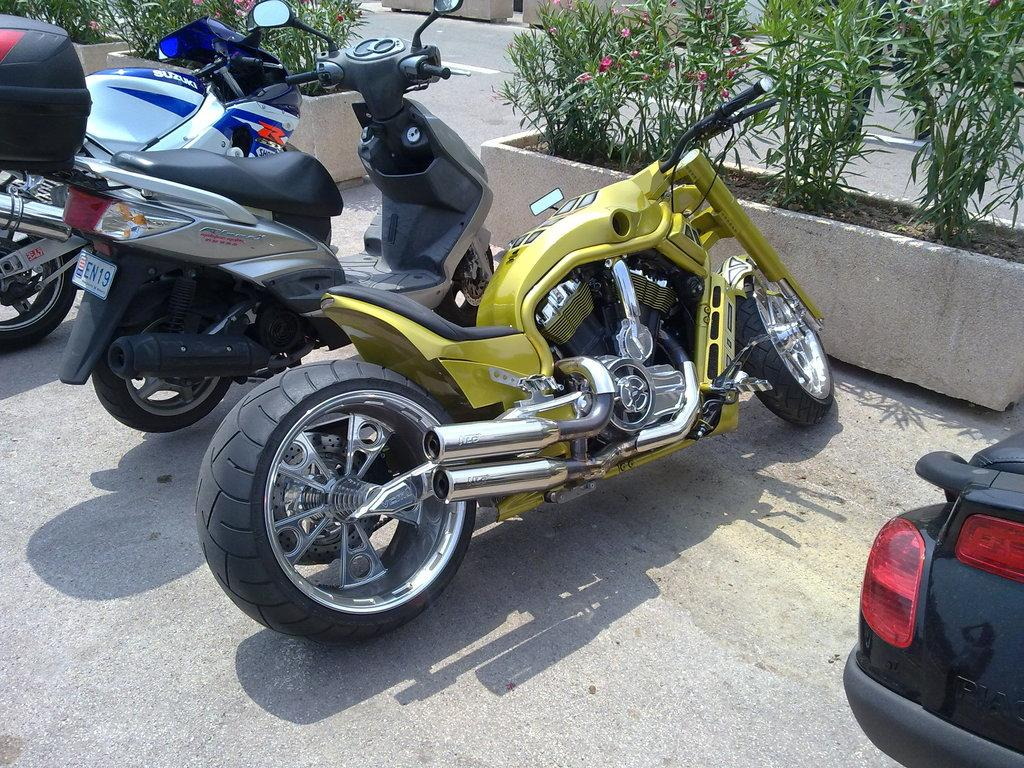What can be seen on the road in the image? There are vehicles on the road in the image. What is located in front of the vehicles in the image? There are plants and flowers in front of the vehicles in the image. Where is the lunchroom located in the image? There is no lunchroom present in the image. What type of health benefits can be gained from the flowers in the image? The image does not provide information about the health benefits of the flowers. 